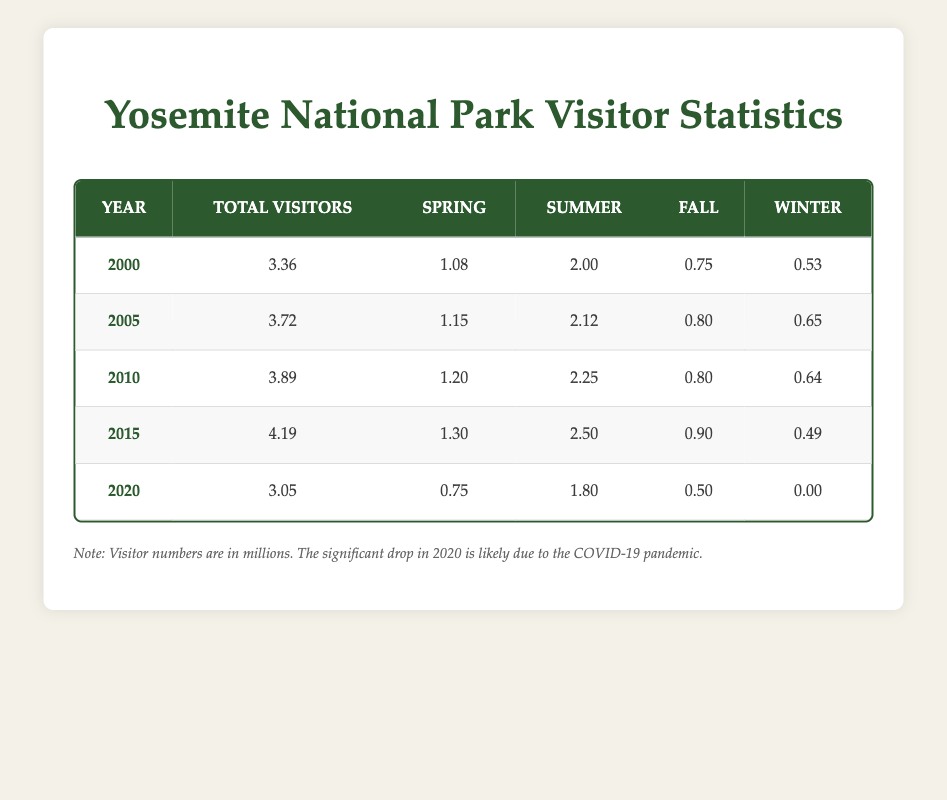What was the total number of visitors to Yosemite in 2005? The table shows that the total visitors in 2005 is listed in the "Total Visitors" column. For 2005, this value is 3.72 million.
Answer: 3.72 million In which year did Yosemite National Park have the highest number of total visitors? To find the year with the highest total visitors, we compare the "Total Visitors" values across all years. The highest value is 4.19 million, which occurred in 2015.
Answer: 2015 What was the total number of visitors in winter of 2020? In 2020, the number of winter visitors is listed in the "Winter" column. The value for winter visitors in 2020 is 0.00 million.
Answer: 0.00 million Did visitor numbers increase every year from 2000 to 2015? By reviewing the "Total Visitors" for each year, we see that 2000 had 3.36 million, 2005 had 3.72 million, 2010 had 3.89 million, and 2015 had 4.19 million. This shows that visitor numbers consistently increased until 2015. However, in 2020 there was a decrease to 3.05 million. Therefore, the statement is false.
Answer: No What is the average total number of visitors from 2000 to 2015? First, we need the total visitors from 2000 to 2015: 3.36 + 3.72 + 3.89 + 4.19 = 15.16 million. There are 4 years in this range, so the average is calculated as 15.16 million divided by 4, which equals 3.79 million.
Answer: 3.79 million Which season had the most visitors in 2015? In 2015, the number of visitors in each season is found in the respective columns. Summer visitors were 2.50 million, which is more than spring (1.30), fall (0.90), and winter (0.49). Therefore, summer had the most visitors.
Answer: Summer What was the percentage drop in total visitors from 2015 to 2020? To find the percentage drop, first calculate the difference between the total visitors in 2015 (4.19 million) and in 2020 (3.05 million), which is 4.19 - 3.05 = 1.14 million. Then divide the difference by the 2015 figures: (1.14/4.19) * 100 = approximately 27.2%.
Answer: 27.2% How did fall visitor numbers in 2010 compare to those in 2020? By checking the table, fall visitor numbers were 0.80 million in 2010 and 0.50 million in 2020. Comparing the two, the number of fall visitors decreased from 0.80 million to 0.50 million, indicating a decline.
Answer: Decreased What was the total number of visitors in spring across all years (2000-2020)? We need to sum the spring visitors for each year: 1.08 (2000) + 1.15 (2005) + 1.20 (2010) + 1.30 (2015) + 0.75 (2020) = 5.48 million total spring visitors.
Answer: 5.48 million 